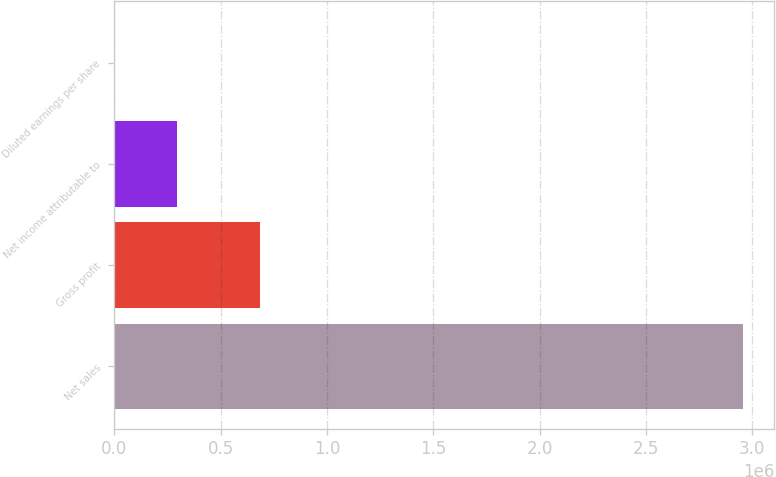Convert chart to OTSL. <chart><loc_0><loc_0><loc_500><loc_500><bar_chart><fcel>Net sales<fcel>Gross profit<fcel>Net income attributable to<fcel>Diluted earnings per share<nl><fcel>2.95715e+06<fcel>684695<fcel>295717<fcel>1.77<nl></chart> 